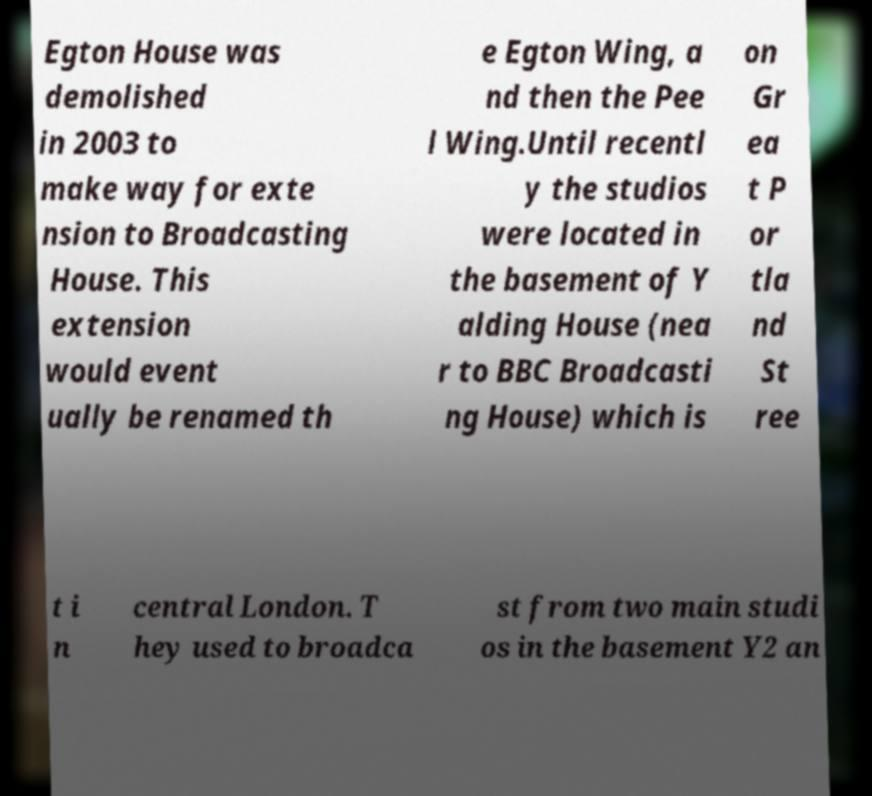What messages or text are displayed in this image? I need them in a readable, typed format. Egton House was demolished in 2003 to make way for exte nsion to Broadcasting House. This extension would event ually be renamed th e Egton Wing, a nd then the Pee l Wing.Until recentl y the studios were located in the basement of Y alding House (nea r to BBC Broadcasti ng House) which is on Gr ea t P or tla nd St ree t i n central London. T hey used to broadca st from two main studi os in the basement Y2 an 